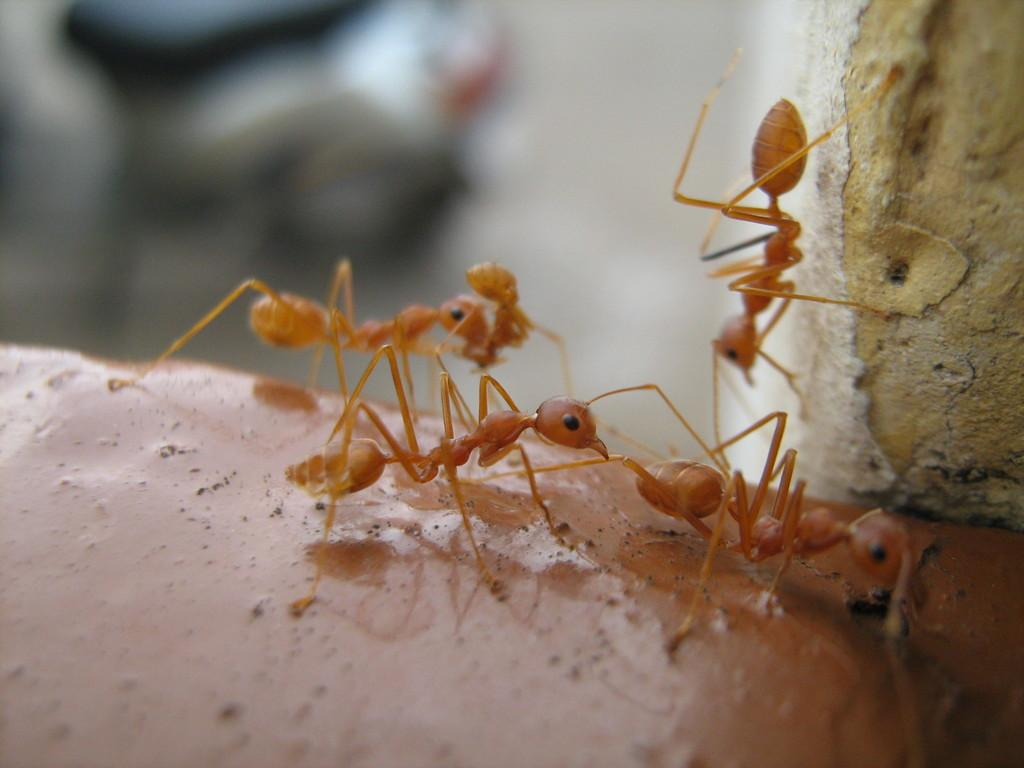What can be observed about the background of the image? The background of the picture is blurred. What creatures are present in the image? There are ants in the image. What is the color of the surface on which the ants are located? The ants are on a brown surface. What type of locket is being used by the ants in the image? There is no locket present in the image; it features ants on a brown surface. What action are the ants performing in the image? The image does not depict any specific action being performed by the ants; they are simply located on a brown surface. 